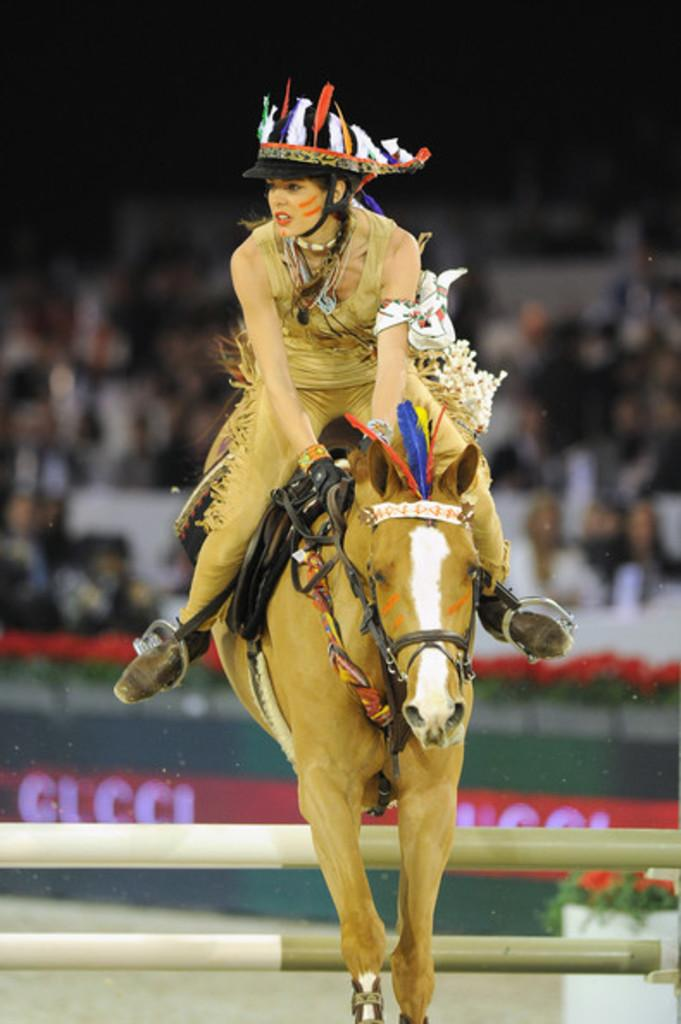Who is the main subject in the image? There is a girl in the image. What is the girl doing in the image? The girl is riding a horse. Where does the image appear to be set? The setting appears to be a playground. Are there any other people visible in the image? Yes, there is an audience visible in the image. Can you hear the owl hooting in the background of the image? There is no owl present in the image, so it cannot be heard hooting in the background. 